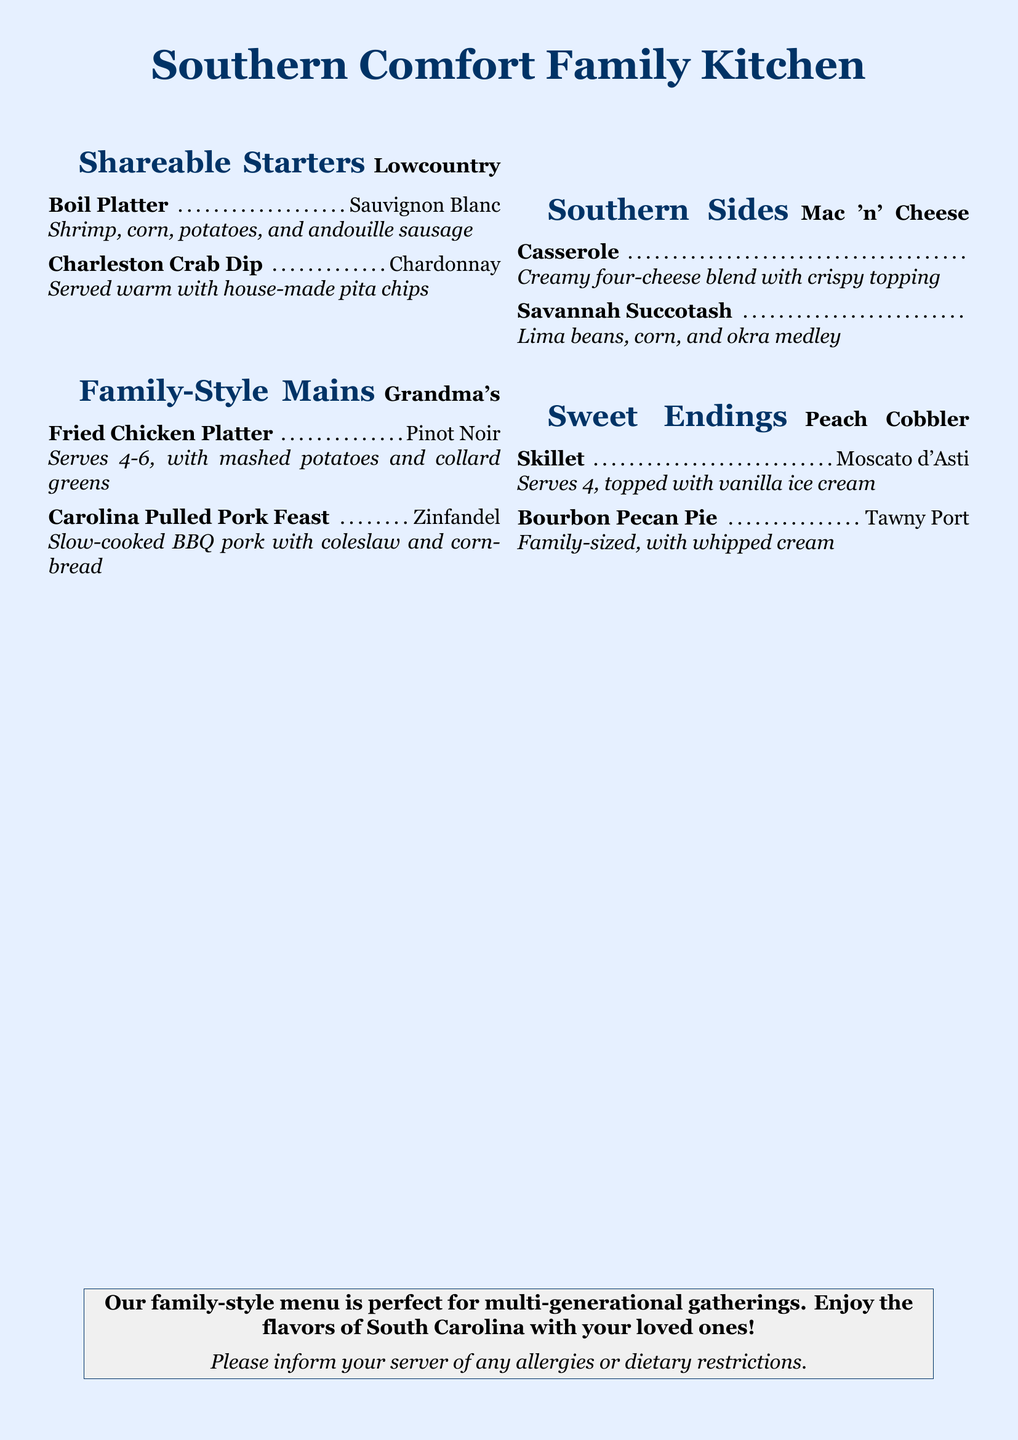what is the name of the restaurant? The restaurant name is prominently displayed at the top of the menu.
Answer: Southern Comfort Family Kitchen how many shareable starters are listed? The number of shareable starters can be counted from the section containing that title.
Answer: 2 what dish comes with a suggested pairing of Sauvignon Blanc? This is found in the Shareable Starters section associated with a specific dish.
Answer: Lowcountry Boil Platter how many people does Grandma's Fried Chicken Platter serve? The serving size is specified in the description of this dish.
Answer: 4-6 what type of wine is recommended with the Bourbon Pecan Pie? This information can be retrieved from the Sweet Endings section of the menu.
Answer: Tawny Port what are the ingredients in the Charleston Crab Dip? The ingredients are listed in the description of the dish in the menu.
Answer: Warm with house-made pita chips which sweet ending serves 4? This detail is included in the description of a specific dessert in the menu.
Answer: Peach Cobbler Skillet what category does the Carolina Pulled Pork Feast belong to? The category can be identified by looking at the heading under which this dish is listed.
Answer: Family-Style Mains is there a suggested pairing for Mac 'n' Cheese Casserole? This can be confirmed by checking the side dish entry in the menu.
Answer: No 